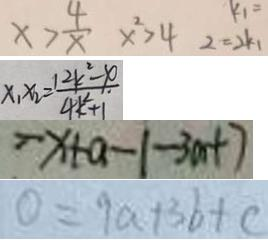<formula> <loc_0><loc_0><loc_500><loc_500>x > \frac { 4 } { x } x ^ { 2 } > 4 2 = 2 k _ { 1 } 
 x _ { 1 } x _ { 2 } = \frac { 1 2 k ^ { 2 } - x } { 4 k ^ { 2 } + 1 } 
 - x + a - 1 - 3 m + 7 
 0 = 9 a + 3 b + c</formula> 